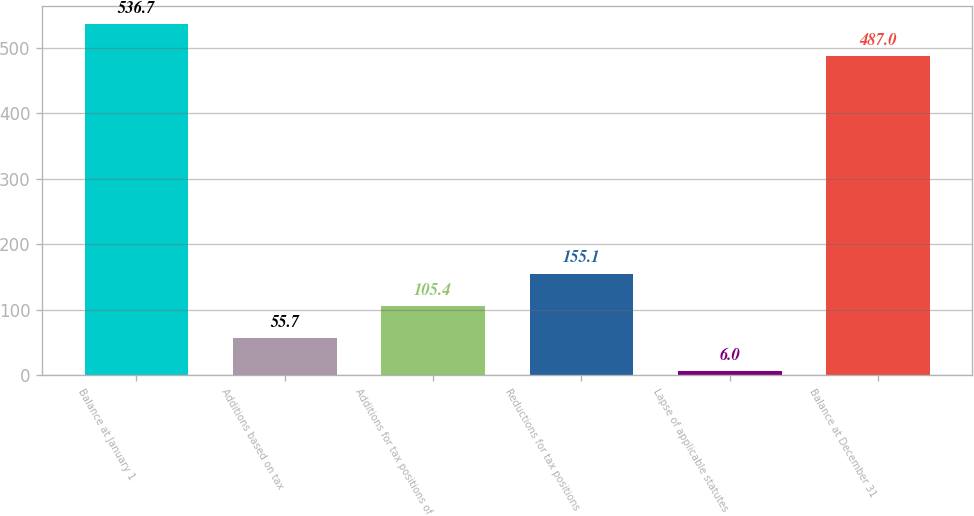<chart> <loc_0><loc_0><loc_500><loc_500><bar_chart><fcel>Balance at January 1<fcel>Additions based on tax<fcel>Additions for tax positions of<fcel>Reductions for tax positions<fcel>Lapse of applicable statutes<fcel>Balance at December 31<nl><fcel>536.7<fcel>55.7<fcel>105.4<fcel>155.1<fcel>6<fcel>487<nl></chart> 